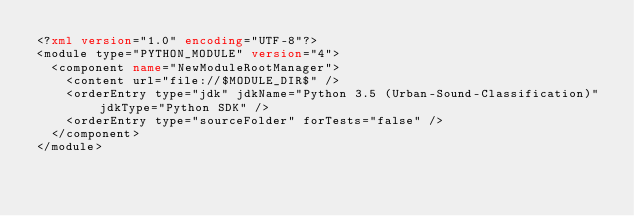Convert code to text. <code><loc_0><loc_0><loc_500><loc_500><_XML_><?xml version="1.0" encoding="UTF-8"?>
<module type="PYTHON_MODULE" version="4">
  <component name="NewModuleRootManager">
    <content url="file://$MODULE_DIR$" />
    <orderEntry type="jdk" jdkName="Python 3.5 (Urban-Sound-Classification)" jdkType="Python SDK" />
    <orderEntry type="sourceFolder" forTests="false" />
  </component>
</module></code> 